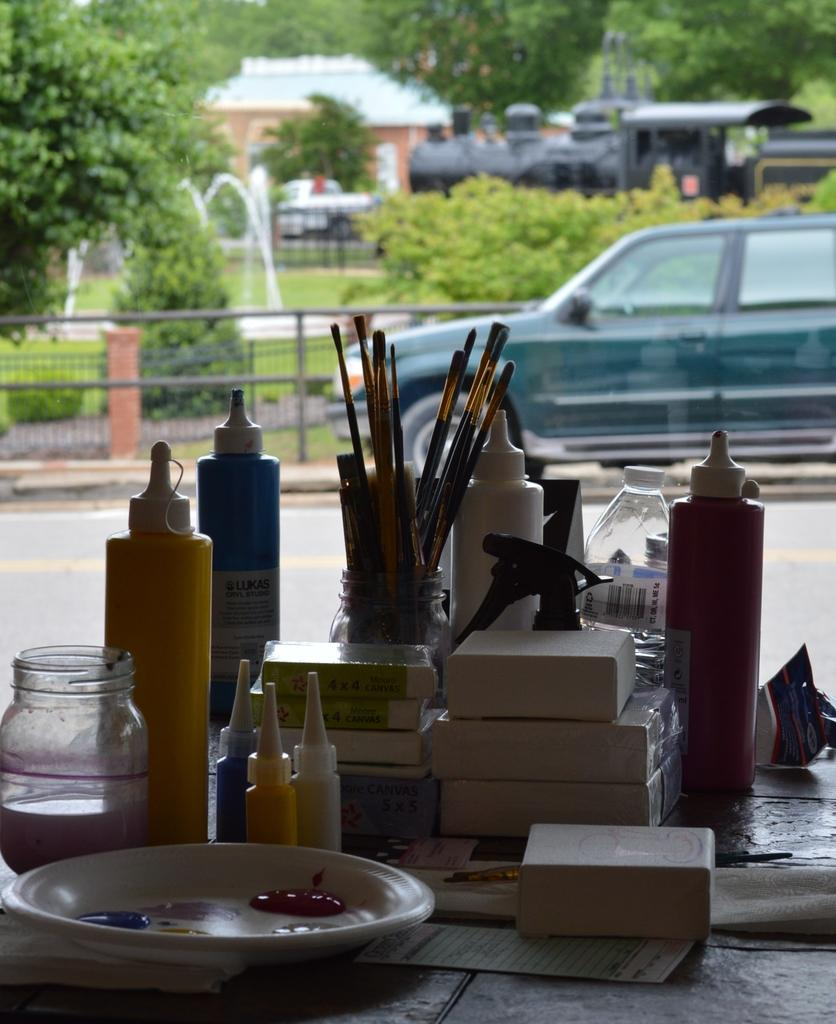What is the main piece of furniture in the image? There is a table in the image. What is placed on the table? There are objects on the table. What can be seen in the distance behind the table? There is a car and trees in the background of the image. What is the angle of the table in the image? The angle of the table cannot be determined from the image, as it appears to be a standard, flat table. 